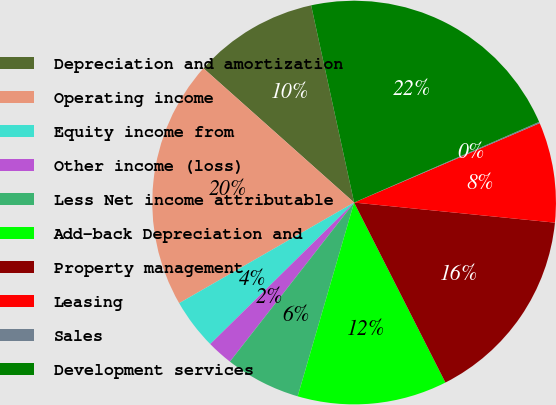Convert chart. <chart><loc_0><loc_0><loc_500><loc_500><pie_chart><fcel>Depreciation and amortization<fcel>Operating income<fcel>Equity income from<fcel>Other income (loss)<fcel>Less Net income attributable<fcel>Add-back Depreciation and<fcel>Property management<fcel>Leasing<fcel>Sales<fcel>Development services<nl><fcel>10.0%<fcel>19.89%<fcel>4.06%<fcel>2.08%<fcel>6.04%<fcel>11.98%<fcel>15.94%<fcel>8.02%<fcel>0.11%<fcel>21.87%<nl></chart> 